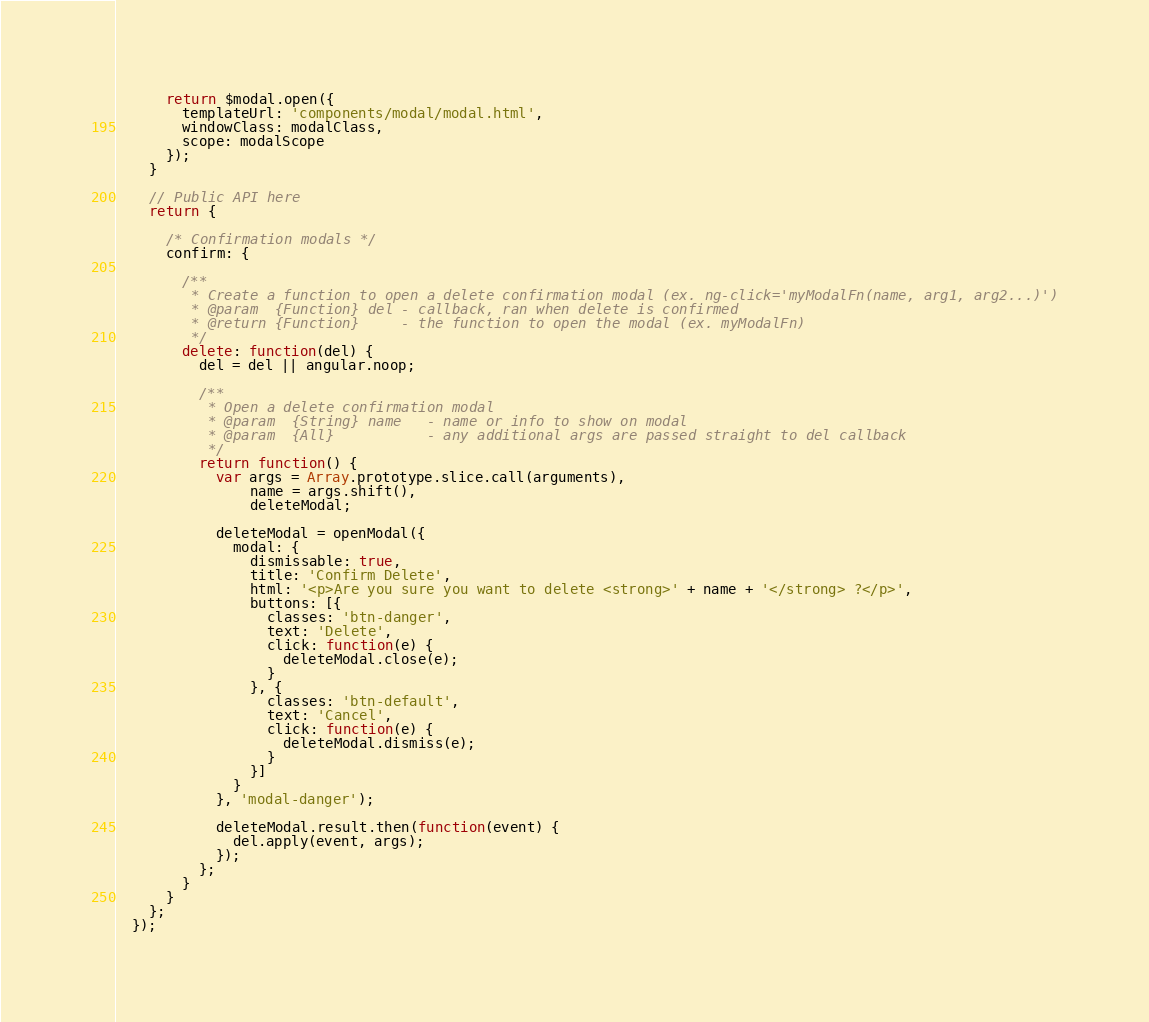<code> <loc_0><loc_0><loc_500><loc_500><_JavaScript_>
      return $modal.open({
        templateUrl: 'components/modal/modal.html',
        windowClass: modalClass,
        scope: modalScope
      });
    }

    // Public API here
    return {

      /* Confirmation modals */
      confirm: {

        /**
         * Create a function to open a delete confirmation modal (ex. ng-click='myModalFn(name, arg1, arg2...)')
         * @param  {Function} del - callback, ran when delete is confirmed
         * @return {Function}     - the function to open the modal (ex. myModalFn)
         */
        delete: function(del) {
          del = del || angular.noop;

          /**
           * Open a delete confirmation modal
           * @param  {String} name   - name or info to show on modal
           * @param  {All}           - any additional args are passed straight to del callback
           */
          return function() {
            var args = Array.prototype.slice.call(arguments),
                name = args.shift(),
                deleteModal;

            deleteModal = openModal({
              modal: {
                dismissable: true,
                title: 'Confirm Delete',
                html: '<p>Are you sure you want to delete <strong>' + name + '</strong> ?</p>',
                buttons: [{
                  classes: 'btn-danger',
                  text: 'Delete',
                  click: function(e) {
                    deleteModal.close(e);
                  }
                }, {
                  classes: 'btn-default',
                  text: 'Cancel',
                  click: function(e) {
                    deleteModal.dismiss(e);
                  }
                }]
              }
            }, 'modal-danger');

            deleteModal.result.then(function(event) {
              del.apply(event, args);
            });
          };
        }
      }
    };
  });
</code> 